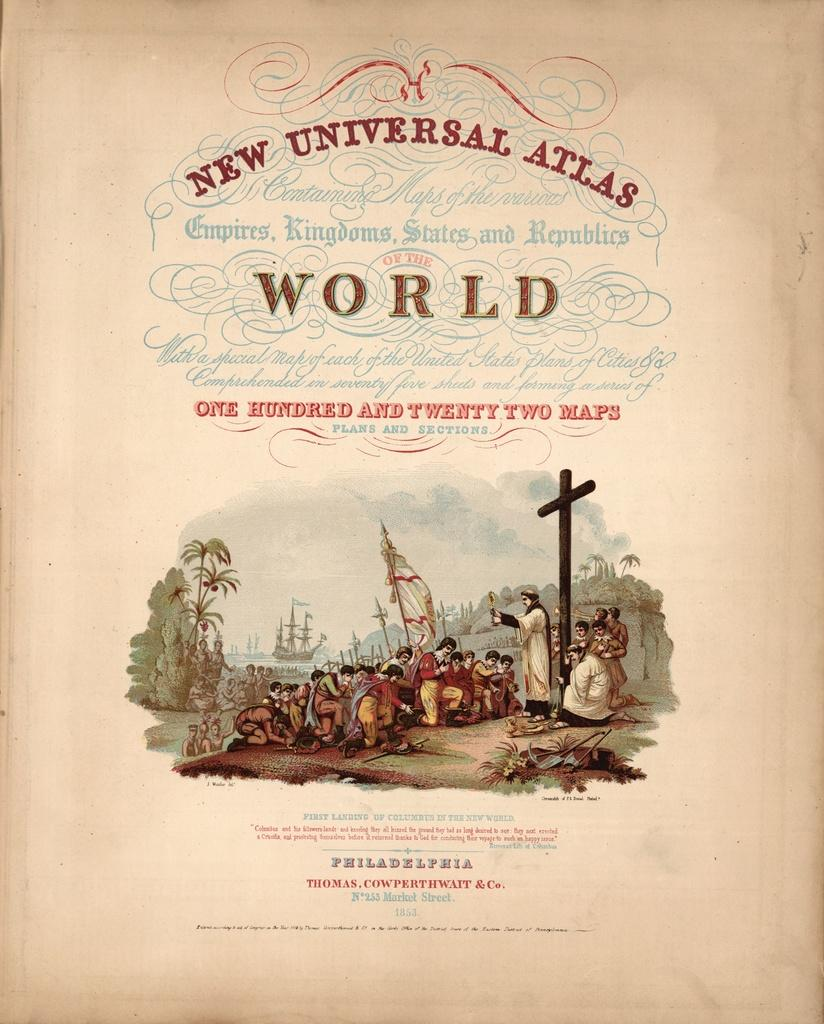<image>
Present a compact description of the photo's key features. The New Universal Atlas of the World was published in Philadelphia. 